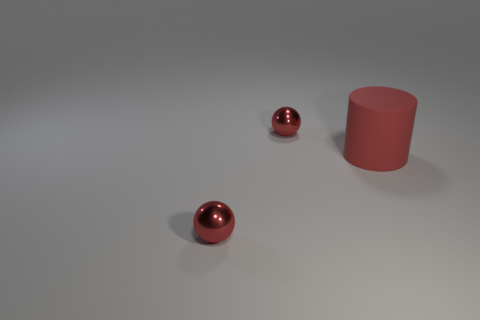Add 3 small metallic spheres. How many objects exist? 6 Subtract all balls. How many objects are left? 1 Subtract all big green metallic objects. Subtract all red spheres. How many objects are left? 1 Add 3 red metallic objects. How many red metallic objects are left? 5 Add 2 large red things. How many large red things exist? 3 Subtract 0 green cubes. How many objects are left? 3 